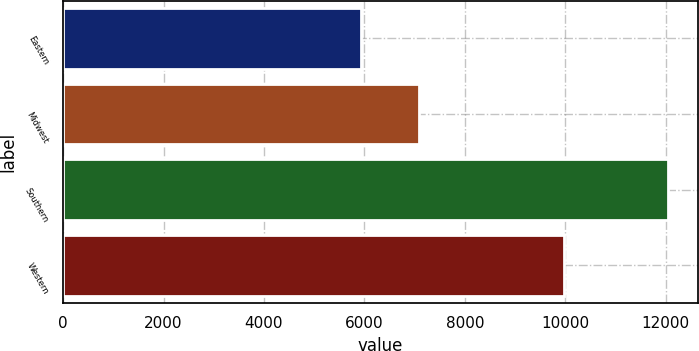Convert chart to OTSL. <chart><loc_0><loc_0><loc_500><loc_500><bar_chart><fcel>Eastern<fcel>Midwest<fcel>Southern<fcel>Western<nl><fcel>5934<fcel>7081<fcel>12039<fcel>9981<nl></chart> 